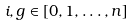Convert formula to latex. <formula><loc_0><loc_0><loc_500><loc_500>i , g \in [ 0 , 1 , \dots , n ]</formula> 